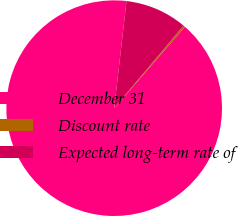Convert chart. <chart><loc_0><loc_0><loc_500><loc_500><pie_chart><fcel>December 31<fcel>Discount rate<fcel>Expected long-term rate of<nl><fcel>90.44%<fcel>0.27%<fcel>9.29%<nl></chart> 